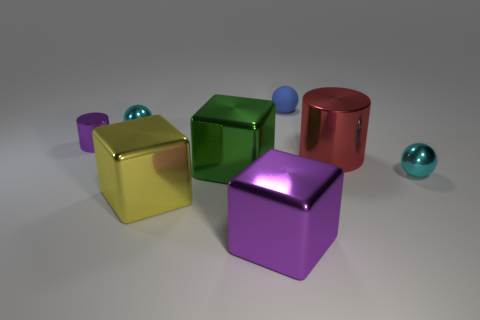Subtract all big yellow blocks. How many blocks are left? 2 Add 1 objects. How many objects exist? 9 Subtract 1 spheres. How many spheres are left? 2 Subtract all yellow cubes. How many cyan balls are left? 2 Subtract all balls. How many objects are left? 5 Subtract all yellow balls. Subtract all cyan cylinders. How many balls are left? 3 Add 8 small purple cylinders. How many small purple cylinders are left? 9 Add 8 big red shiny cylinders. How many big red shiny cylinders exist? 9 Subtract 0 purple spheres. How many objects are left? 8 Subtract all small matte objects. Subtract all matte spheres. How many objects are left? 6 